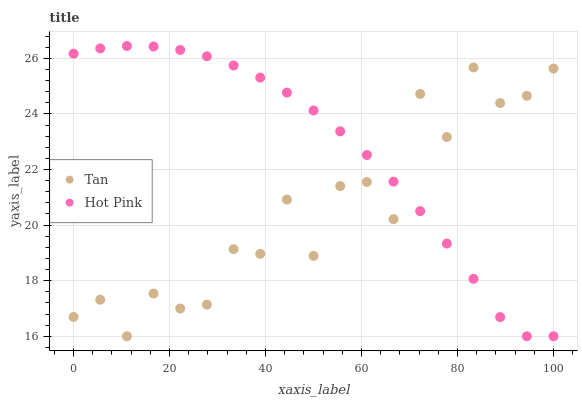Does Tan have the minimum area under the curve?
Answer yes or no. Yes. Does Hot Pink have the maximum area under the curve?
Answer yes or no. Yes. Does Hot Pink have the minimum area under the curve?
Answer yes or no. No. Is Hot Pink the smoothest?
Answer yes or no. Yes. Is Tan the roughest?
Answer yes or no. Yes. Is Hot Pink the roughest?
Answer yes or no. No. Does Tan have the lowest value?
Answer yes or no. Yes. Does Hot Pink have the highest value?
Answer yes or no. Yes. Does Tan intersect Hot Pink?
Answer yes or no. Yes. Is Tan less than Hot Pink?
Answer yes or no. No. Is Tan greater than Hot Pink?
Answer yes or no. No. 